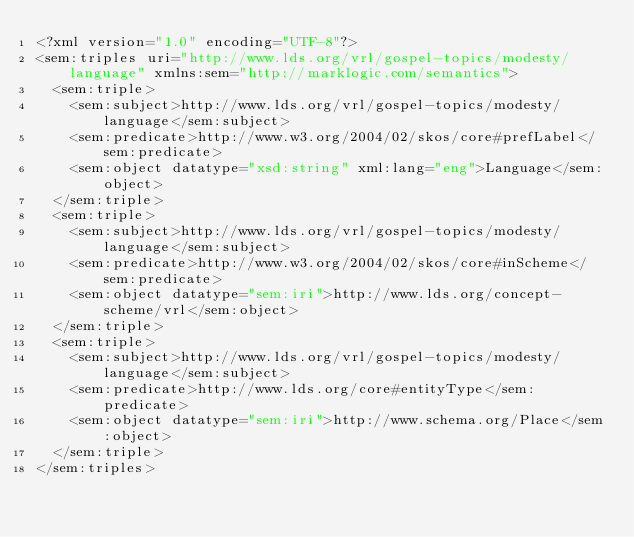Convert code to text. <code><loc_0><loc_0><loc_500><loc_500><_XML_><?xml version="1.0" encoding="UTF-8"?>
<sem:triples uri="http://www.lds.org/vrl/gospel-topics/modesty/language" xmlns:sem="http://marklogic.com/semantics">
  <sem:triple>
    <sem:subject>http://www.lds.org/vrl/gospel-topics/modesty/language</sem:subject>
    <sem:predicate>http://www.w3.org/2004/02/skos/core#prefLabel</sem:predicate>
    <sem:object datatype="xsd:string" xml:lang="eng">Language</sem:object>
  </sem:triple>
  <sem:triple>
    <sem:subject>http://www.lds.org/vrl/gospel-topics/modesty/language</sem:subject>
    <sem:predicate>http://www.w3.org/2004/02/skos/core#inScheme</sem:predicate>
    <sem:object datatype="sem:iri">http://www.lds.org/concept-scheme/vrl</sem:object>
  </sem:triple>
  <sem:triple>
    <sem:subject>http://www.lds.org/vrl/gospel-topics/modesty/language</sem:subject>
    <sem:predicate>http://www.lds.org/core#entityType</sem:predicate>
    <sem:object datatype="sem:iri">http://www.schema.org/Place</sem:object>
  </sem:triple>
</sem:triples>
</code> 